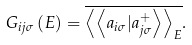<formula> <loc_0><loc_0><loc_500><loc_500>G _ { i j \sigma } \left ( E \right ) = \overline { \left \langle \left \langle a _ { i \sigma } | a ^ { + } _ { j \sigma } \right \rangle \right \rangle _ { E } } .</formula> 